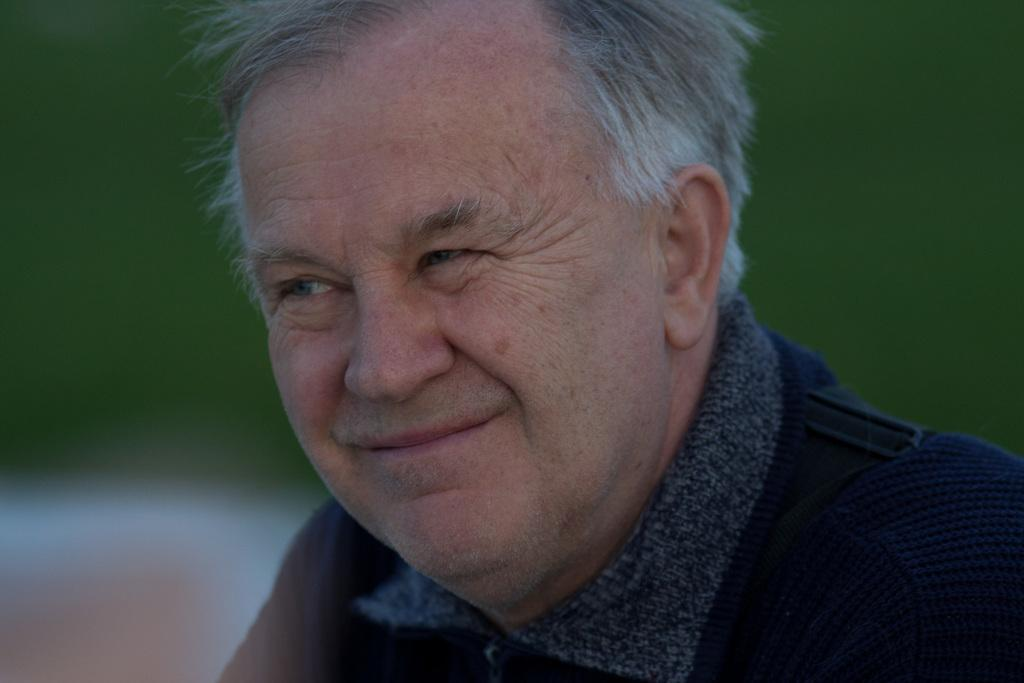Who is the main subject in the image? There is an old man in the image. What is the old man doing in the image? The old man is smiling. What type of stream can be seen flowing behind the old man in the image? There is no stream present in the image; it only features the old man. What kind of soup is the old man holding in the image? There is no soup present in the image; the old man is simply smiling. 